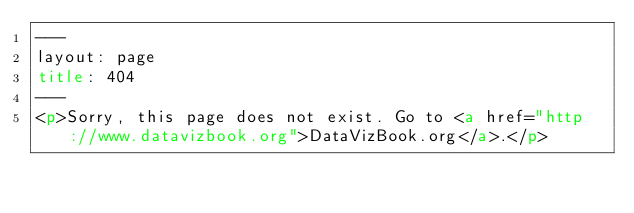<code> <loc_0><loc_0><loc_500><loc_500><_HTML_>---
layout: page
title: 404
---
<p>Sorry, this page does not exist. Go to <a href="http://www.datavizbook.org">DataVizBook.org</a>.</p>
</code> 